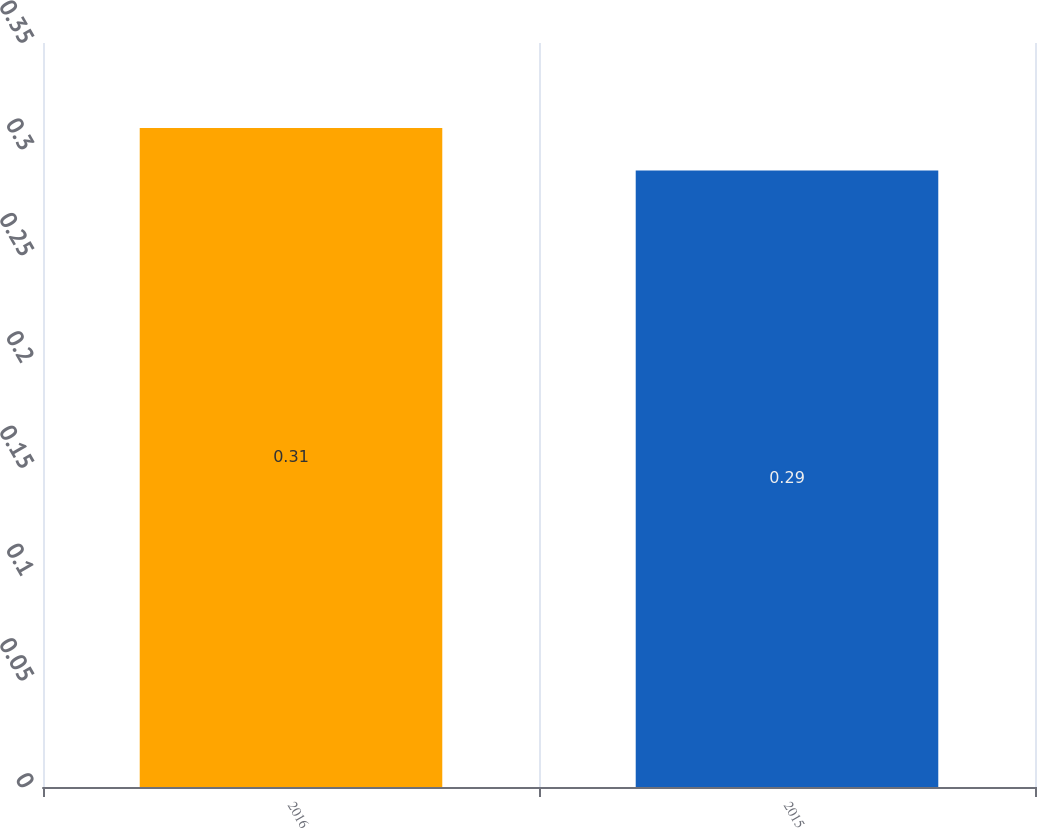<chart> <loc_0><loc_0><loc_500><loc_500><bar_chart><fcel>2016<fcel>2015<nl><fcel>0.31<fcel>0.29<nl></chart> 